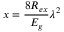Convert formula to latex. <formula><loc_0><loc_0><loc_500><loc_500>x = \frac { 8 R _ { e x } } { E _ { g } } \lambda ^ { 2 }</formula> 